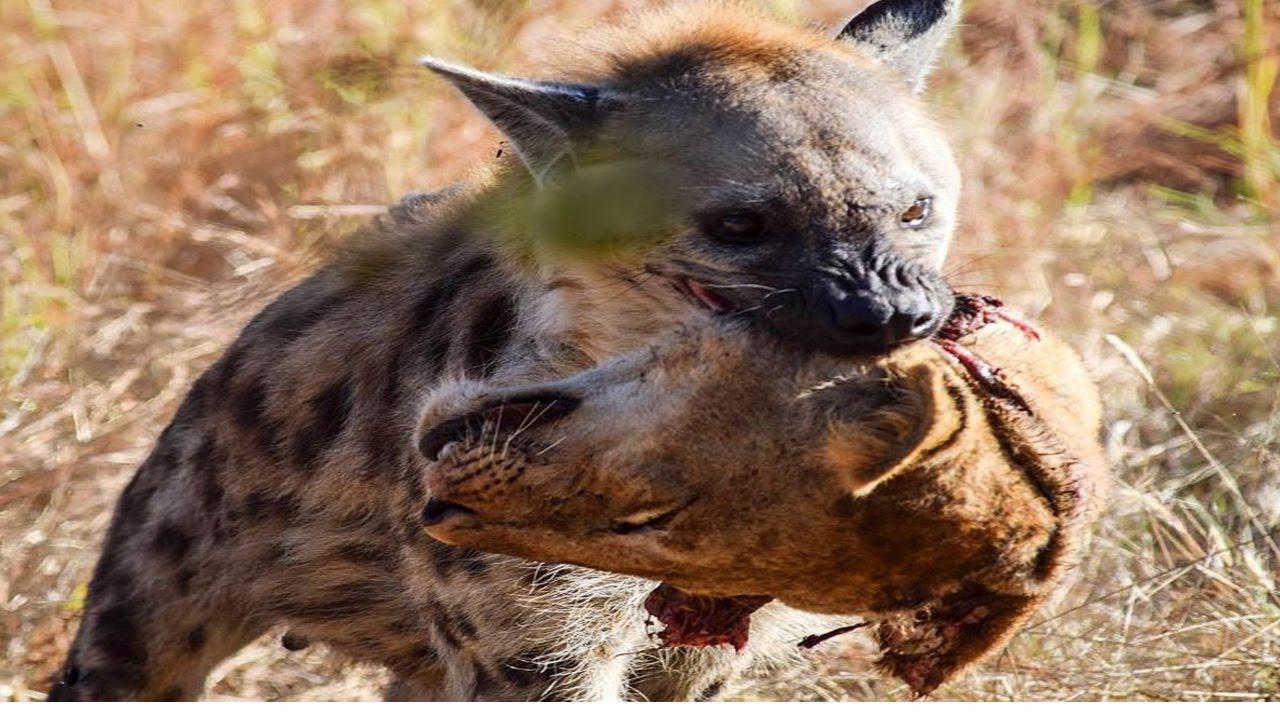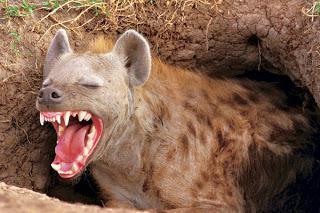The first image is the image on the left, the second image is the image on the right. Considering the images on both sides, is "The hyena in the right image is baring its teeth." valid? Answer yes or no. Yes. 